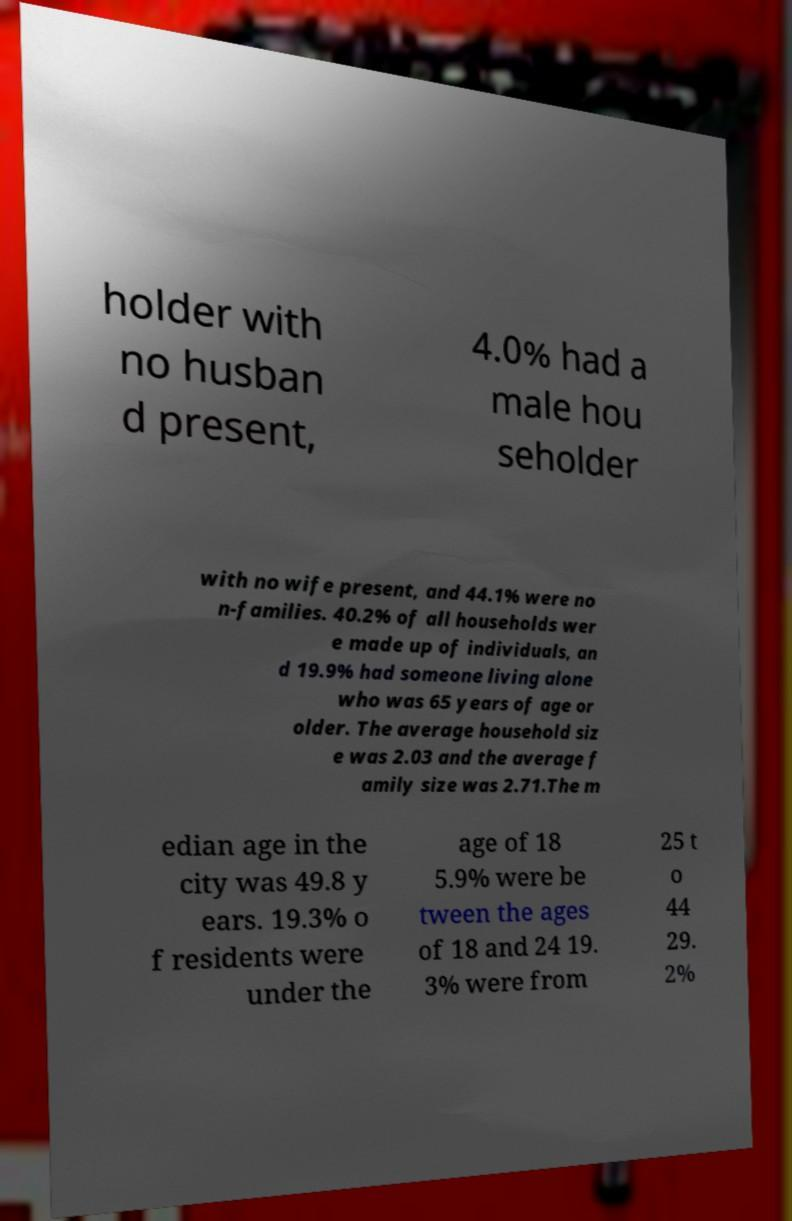I need the written content from this picture converted into text. Can you do that? holder with no husban d present, 4.0% had a male hou seholder with no wife present, and 44.1% were no n-families. 40.2% of all households wer e made up of individuals, an d 19.9% had someone living alone who was 65 years of age or older. The average household siz e was 2.03 and the average f amily size was 2.71.The m edian age in the city was 49.8 y ears. 19.3% o f residents were under the age of 18 5.9% were be tween the ages of 18 and 24 19. 3% were from 25 t o 44 29. 2% 